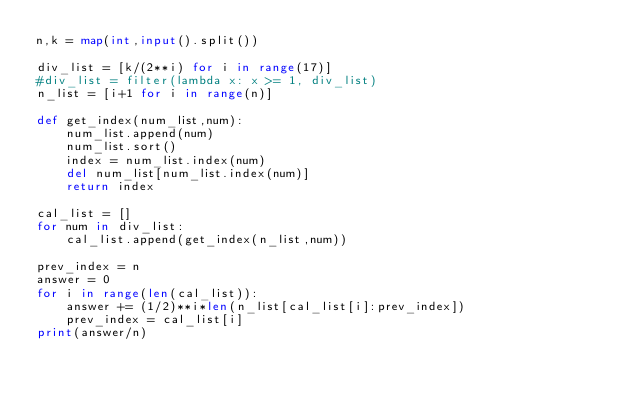<code> <loc_0><loc_0><loc_500><loc_500><_Python_>n,k = map(int,input().split())

div_list = [k/(2**i) for i in range(17)]
#div_list = filter(lambda x: x >= 1, div_list) 
n_list = [i+1 for i in range(n)]

def get_index(num_list,num):
    num_list.append(num)
    num_list.sort()
    index = num_list.index(num)
    del num_list[num_list.index(num)]
    return index

cal_list = []
for num in div_list:
    cal_list.append(get_index(n_list,num))

prev_index = n
answer = 0
for i in range(len(cal_list)):
    answer += (1/2)**i*len(n_list[cal_list[i]:prev_index])
    prev_index = cal_list[i]
print(answer/n)</code> 